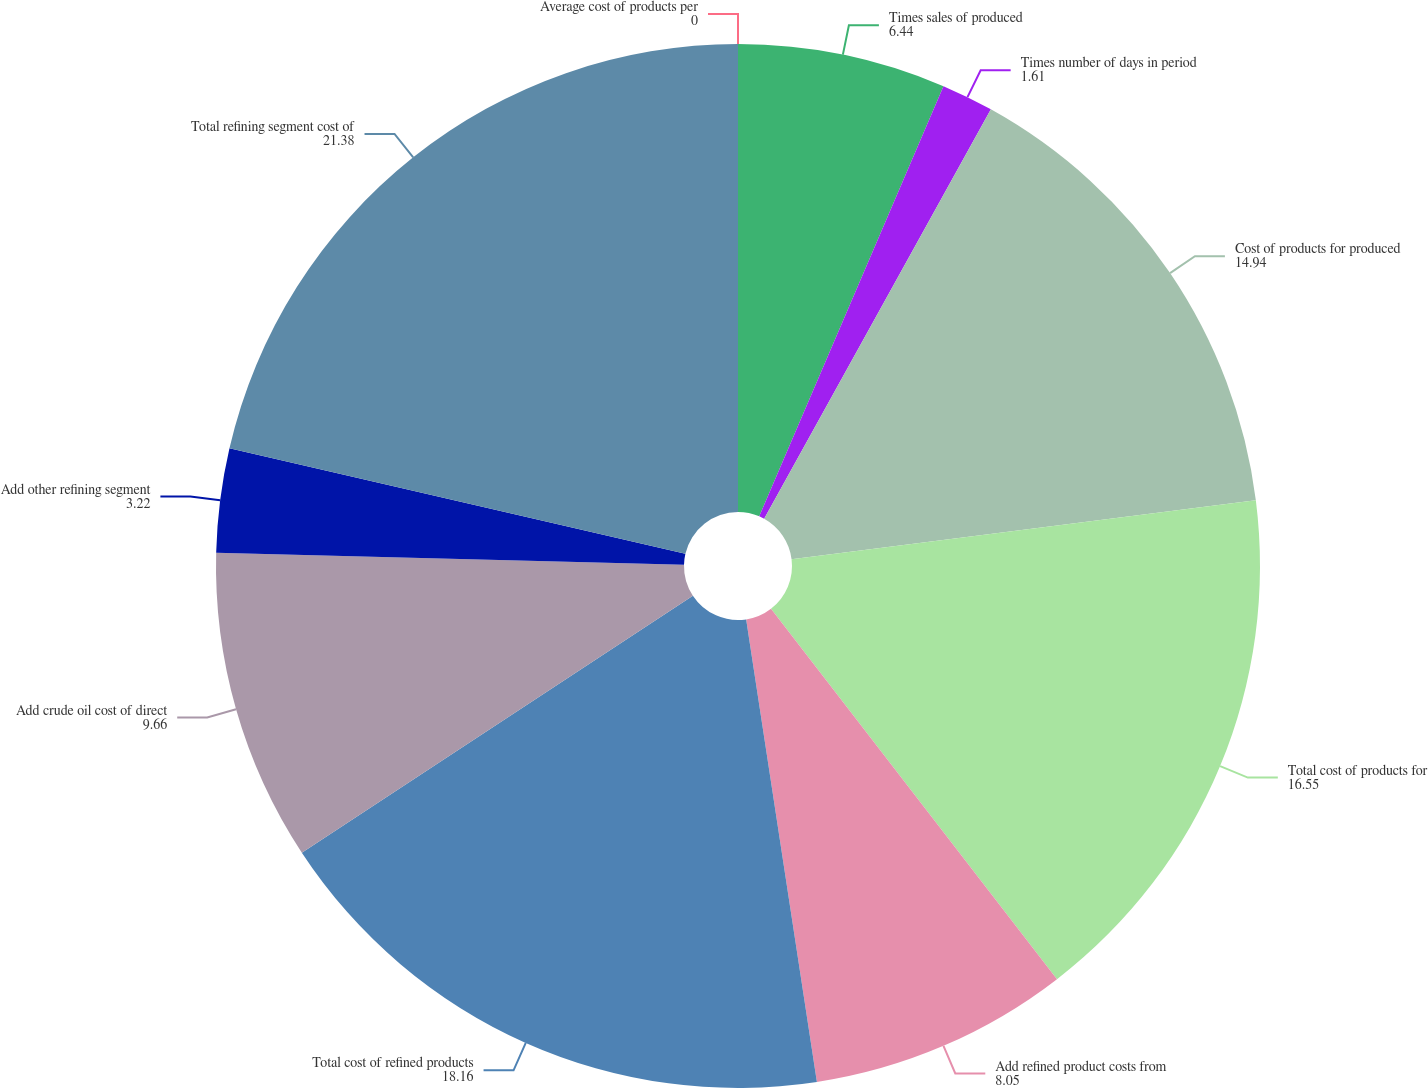Convert chart to OTSL. <chart><loc_0><loc_0><loc_500><loc_500><pie_chart><fcel>Average cost of products per<fcel>Times sales of produced<fcel>Times number of days in period<fcel>Cost of products for produced<fcel>Total cost of products for<fcel>Add refined product costs from<fcel>Total cost of refined products<fcel>Add crude oil cost of direct<fcel>Add other refining segment<fcel>Total refining segment cost of<nl><fcel>0.0%<fcel>6.44%<fcel>1.61%<fcel>14.94%<fcel>16.55%<fcel>8.05%<fcel>18.16%<fcel>9.66%<fcel>3.22%<fcel>21.38%<nl></chart> 